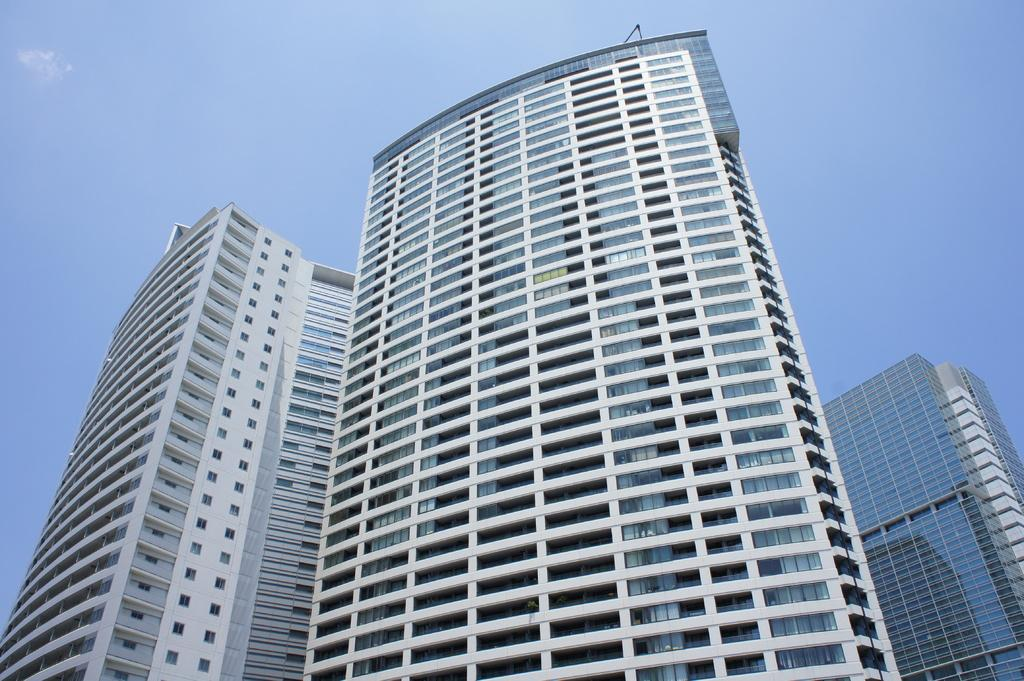What type of structures are present in the image? There are tall buildings in the image. What color is the sky in the image? The sky is blue in the image. Where is the crate located in the image? There is no crate present in the image. What type of book can be seen on the table in the image? There is no table or book present in the image. 